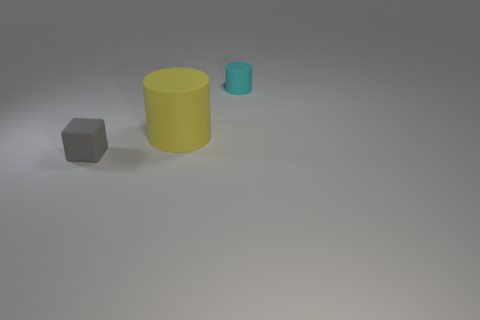Is there anything else that is the same size as the yellow rubber cylinder?
Keep it short and to the point. No. The tiny object that is in front of the small object to the right of the tiny rubber object on the left side of the cyan cylinder is what shape?
Your answer should be compact. Cube. How many other tiny cylinders have the same color as the tiny cylinder?
Your answer should be compact. 0. What is the material of the yellow object?
Give a very brief answer. Rubber. Is the material of the thing that is right of the yellow thing the same as the small gray object?
Provide a short and direct response. Yes. What is the shape of the tiny object that is in front of the tiny cyan object?
Ensure brevity in your answer.  Cube. How many things are objects behind the small rubber block or matte cylinders on the right side of the big yellow object?
Offer a very short reply. 2. What is the size of the yellow object that is made of the same material as the cyan cylinder?
Make the answer very short. Large. What number of matte things are either small cyan cylinders or small red spheres?
Provide a short and direct response. 1. How big is the yellow matte cylinder?
Your answer should be compact. Large. 